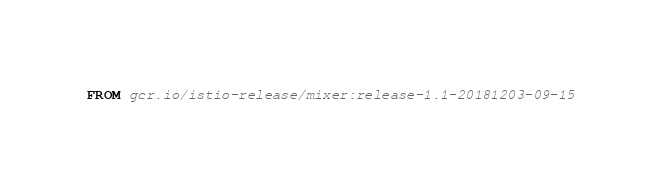<code> <loc_0><loc_0><loc_500><loc_500><_Dockerfile_>FROM gcr.io/istio-release/mixer:release-1.1-20181203-09-15
</code> 